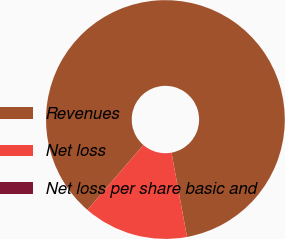<chart> <loc_0><loc_0><loc_500><loc_500><pie_chart><fcel>Revenues<fcel>Net loss<fcel>Net loss per share basic and<nl><fcel>85.77%<fcel>14.23%<fcel>0.0%<nl></chart> 